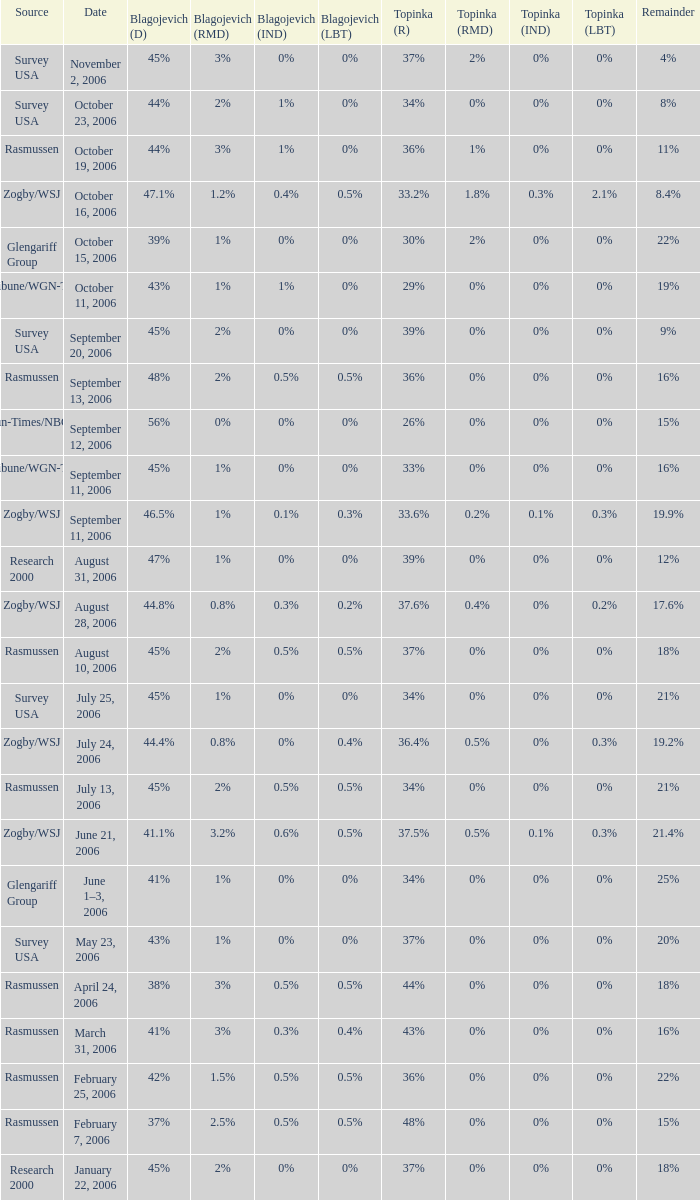Which date has a surplus of 20%? May 23, 2006. 